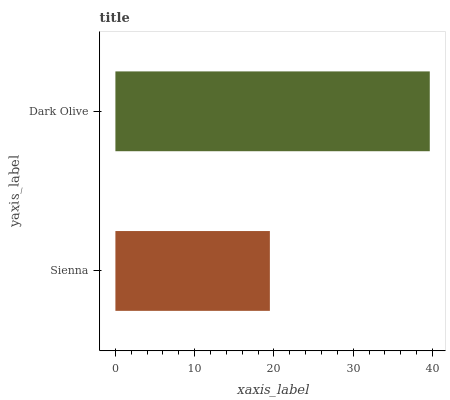Is Sienna the minimum?
Answer yes or no. Yes. Is Dark Olive the maximum?
Answer yes or no. Yes. Is Dark Olive the minimum?
Answer yes or no. No. Is Dark Olive greater than Sienna?
Answer yes or no. Yes. Is Sienna less than Dark Olive?
Answer yes or no. Yes. Is Sienna greater than Dark Olive?
Answer yes or no. No. Is Dark Olive less than Sienna?
Answer yes or no. No. Is Dark Olive the high median?
Answer yes or no. Yes. Is Sienna the low median?
Answer yes or no. Yes. Is Sienna the high median?
Answer yes or no. No. Is Dark Olive the low median?
Answer yes or no. No. 